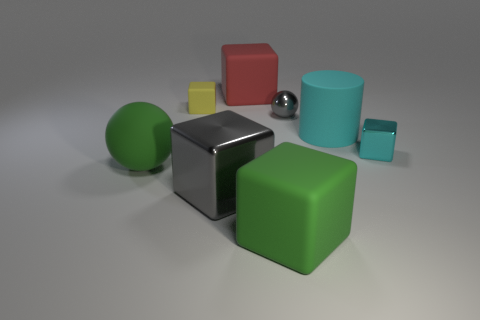Subtract 1 blocks. How many blocks are left? 4 Subtract all cyan cubes. How many cubes are left? 4 Subtract all brown blocks. Subtract all brown spheres. How many blocks are left? 5 Add 2 cyan matte things. How many objects exist? 10 Subtract all cylinders. How many objects are left? 7 Subtract 1 green cubes. How many objects are left? 7 Subtract all large red things. Subtract all small blocks. How many objects are left? 5 Add 2 rubber objects. How many rubber objects are left? 7 Add 1 big objects. How many big objects exist? 6 